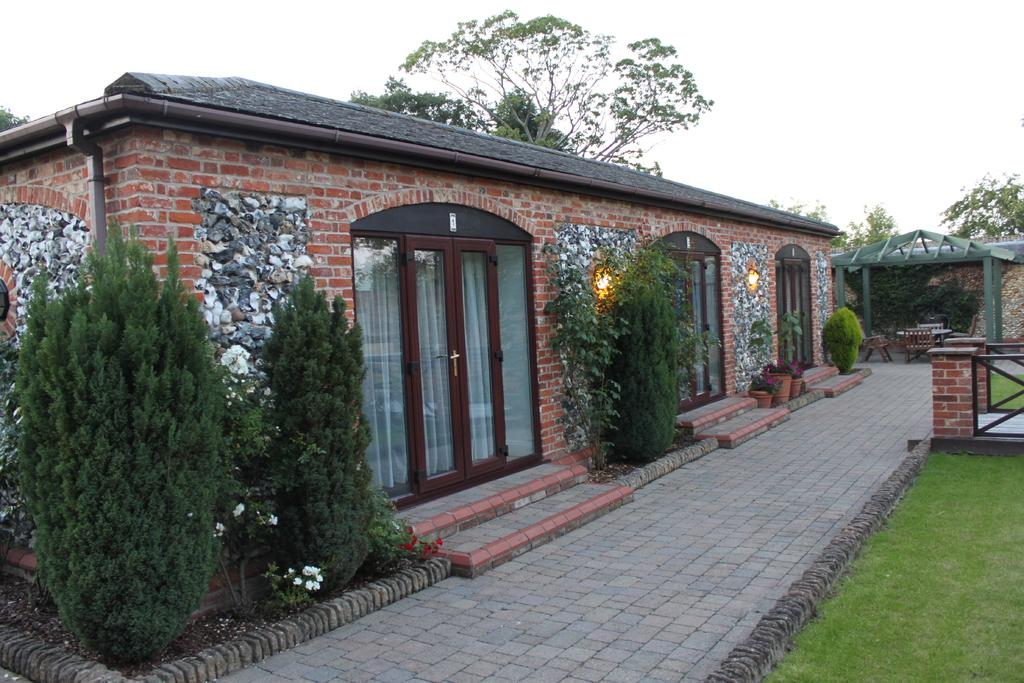What type of structure can be seen in the image? There is a shed in the image. What natural elements are present in the image? There are trees, plants, and flowers in the image. Can you describe the containers for the plants in the image? There are flower pots in the image. What is the purpose of the railing in the image? The railing in the image may provide support or serve as a barrier. What part of the ground is visible in the image? The ground is visible at the bottom of the image. What type of rice can be seen growing in the image? There is no rice present in the image; it features a shed, trees, plants, flowers, flower pots, a railing, and the ground. How does the love between the flowers manifest in the image? The image does not depict love between the flowers or any other elements; it is a visual representation of a shed, trees, plants, flowers, flower pots, a railing, and the ground. 